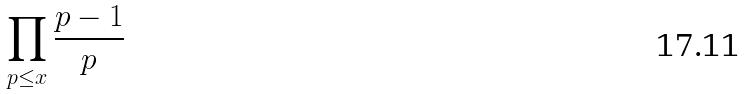Convert formula to latex. <formula><loc_0><loc_0><loc_500><loc_500>\prod _ { p \leq x } \frac { p - 1 } { p }</formula> 